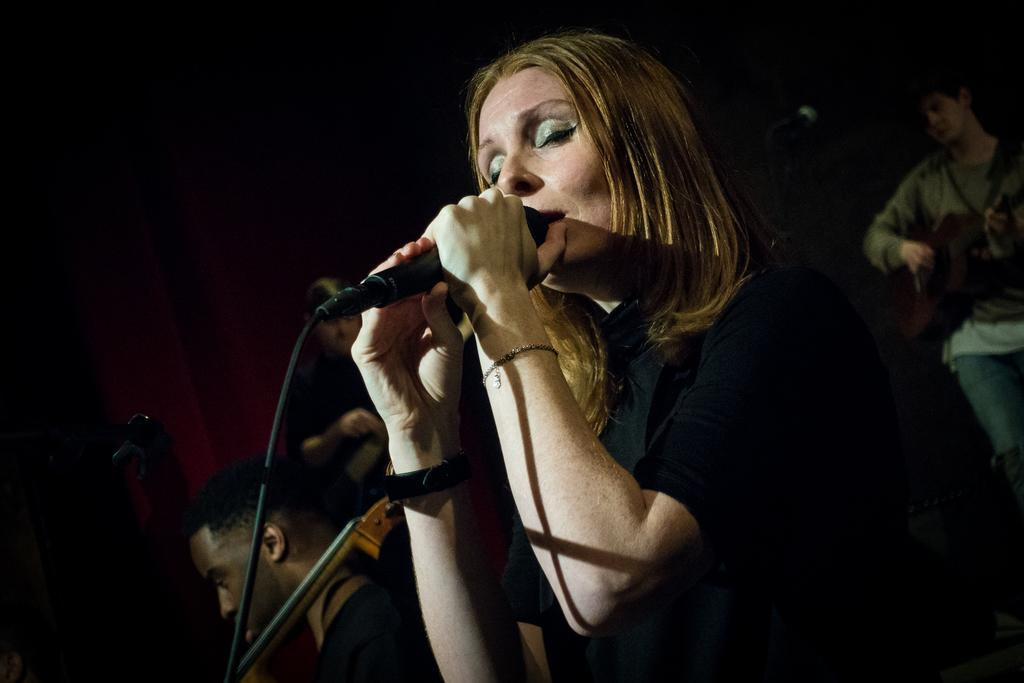Who is the main subject in the image? There is a lady in the center of the image. What is the lady holding in her hands? The lady is holding a mic in her hands. Can you describe the people in the background of the image? There are other people in the background of the image. What type of cherry is the lady holding in her hand? The lady is not holding a cherry in her hand; she is holding a mic. Can you see a pen being used by any of the people in the image? There is no pen visible in the image. 